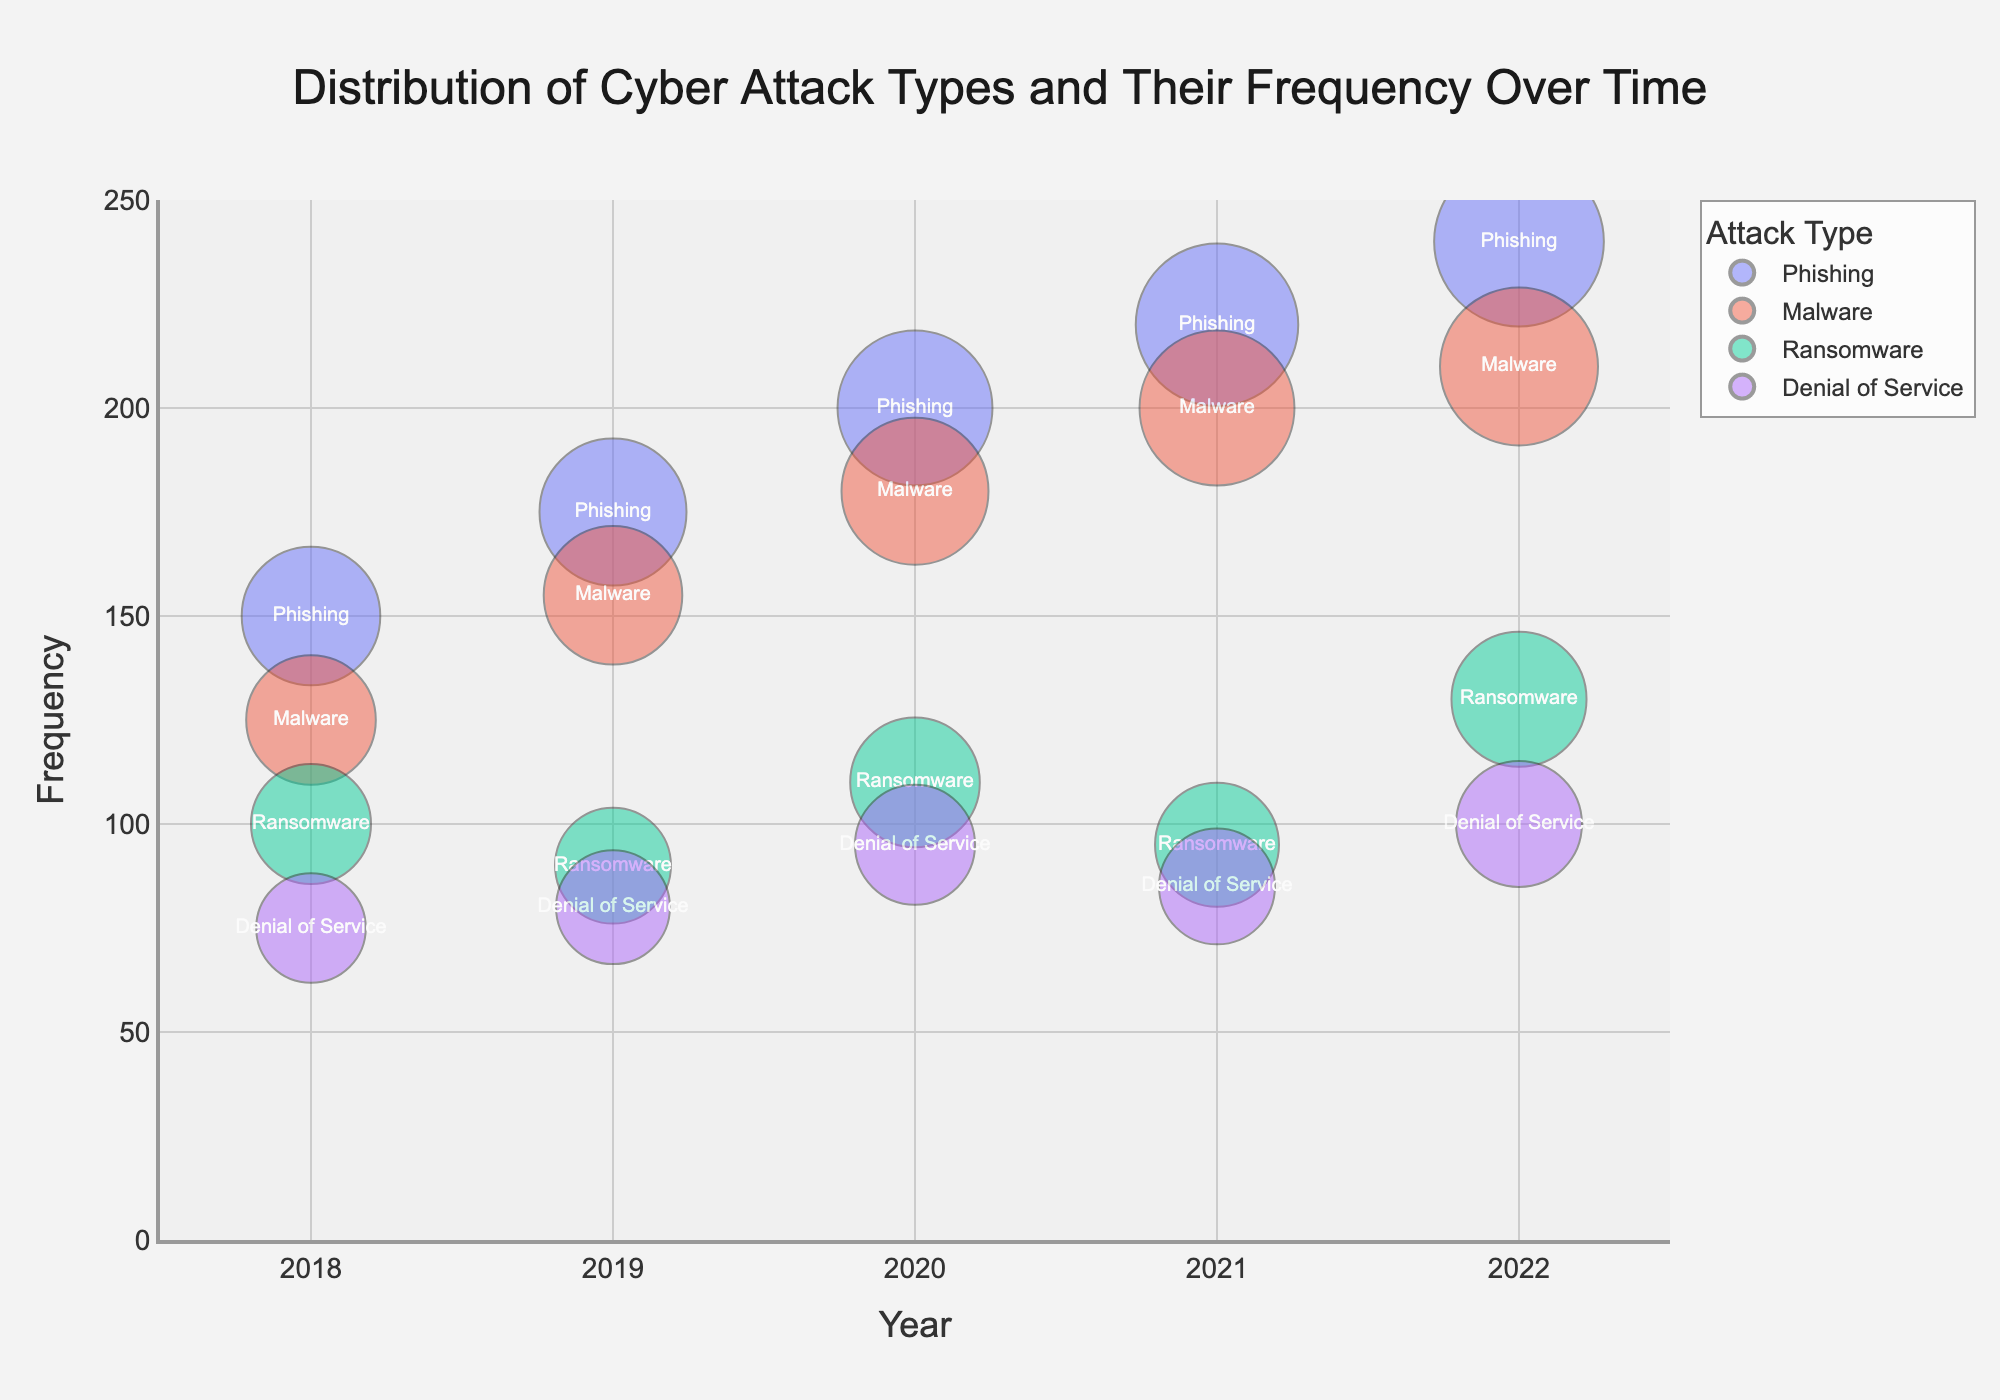What is the title of the bubble chart? The title appears at the top center of the bubble chart and is often the first element noticed.
Answer: Distribution of Cyber Attack Types and Their Frequency Over Time Which year had the highest frequency of phishing attacks? Look for the largest bubble labeled "Phishing" on the y-axis representing frequency, and then trace it to the x-axis representing the year.
Answer: 2022 How does the frequency of malware attacks in 2018 compare to those in 2020? Locate the bubbles labeled "Malware" for 2018 and 2020 on the y-axis to compare their heights (frequencies).
Answer: Higher in 2020 Which attack type shows an increase in frequency each year from 2018 to 2022? Follow each bubble of the attack types from 2018 to 2022 to determine if the frequency consistently increases.
Answer: Phishing What is the bubble size for ransomware attacks in 2021, and what does it represent? Locate the ransomware bubble for 2021, and hover over it if there's an interactive feature or refer to the data where bubble size is detailed. The bubble size typically represents an attribute like magnitude or impact.
Answer: 32, represents additional metric related to attack magnitude or impact Which attack type had a frequency of 95 in 2020? Locate the y-axis value of 95 for the year 2020 and identify the attack type associated with it.
Answer: Denial of Service What trend can be observed in the frequency of denial of service attacks from 2018 to 2022? Track the bubbles labeled "Denial of Service" across the years, noting any increase or decrease.
Answer: Increasing How does the size of the bubbles for ransomware attacks in 2020 compare to those for malware in 2019? Compare the ransomware bubble size in 2020 with the malware bubble size in 2019 by referring to the respective y-axis values and the visual size differences.
Answer: Slightly larger in 2020 ransomware What is the range for the x-axis (years) in the bubble chart? Observe the lower and upper boundaries of the x-axis values to determine the range.
Answer: 2017.5 to 2022.5 In 2022, which attack type had the smallest bubble size, and what does it suggest? Compare the bubble sizes for each attack type in 2022 and identify the smallest one. The bubble size typically correlates with an additional metric like severity or cost.
Answer: Denial of Service, suggests it had the lowest additional impact or magnitude in that year 